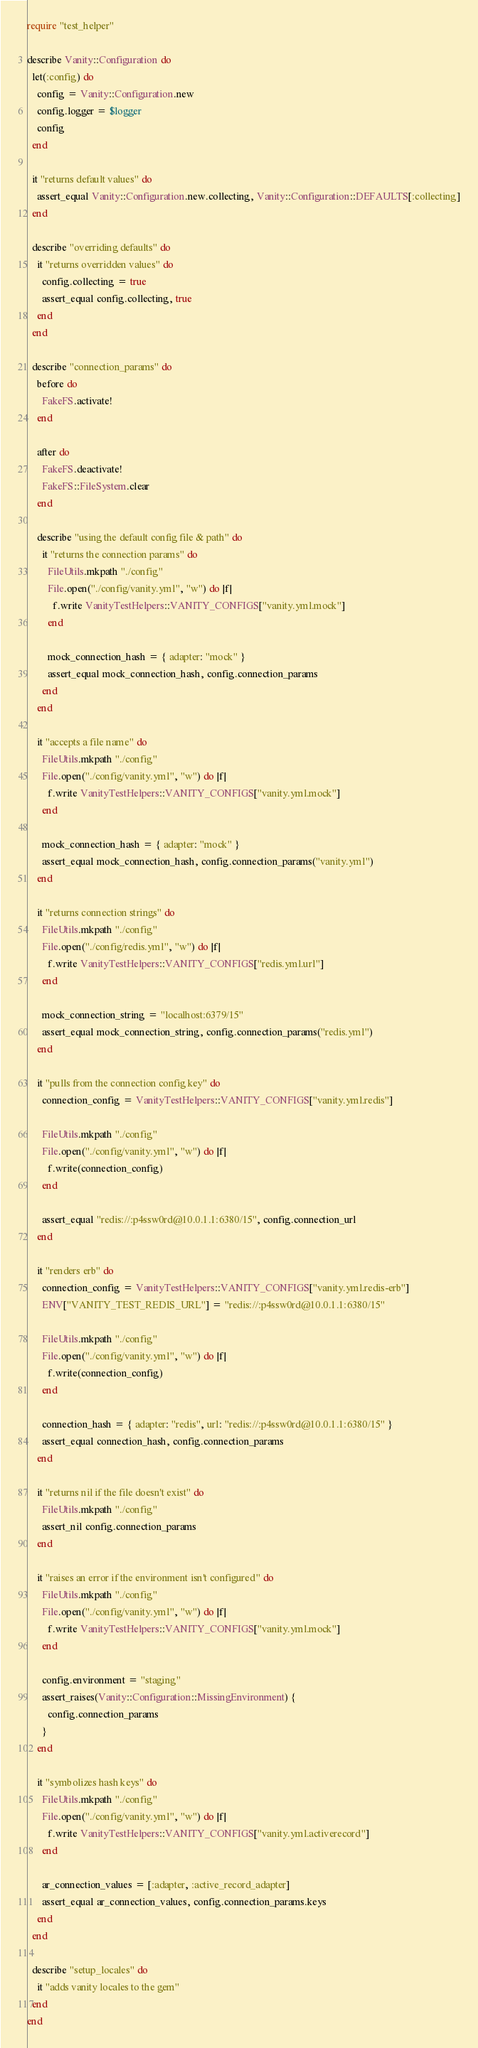<code> <loc_0><loc_0><loc_500><loc_500><_Ruby_>require "test_helper"

describe Vanity::Configuration do
  let(:config) do
    config = Vanity::Configuration.new
    config.logger = $logger
    config
  end

  it "returns default values" do
    assert_equal Vanity::Configuration.new.collecting, Vanity::Configuration::DEFAULTS[:collecting]
  end

  describe "overriding defaults" do
    it "returns overridden values" do
      config.collecting = true
      assert_equal config.collecting, true
    end
  end

  describe "connection_params" do
    before do
      FakeFS.activate!
    end

    after do
      FakeFS.deactivate!
      FakeFS::FileSystem.clear
    end

    describe "using the default config file & path" do
      it "returns the connection params" do
        FileUtils.mkpath "./config"
        File.open("./config/vanity.yml", "w") do |f|
          f.write VanityTestHelpers::VANITY_CONFIGS["vanity.yml.mock"]
        end

        mock_connection_hash = { adapter: "mock" }
        assert_equal mock_connection_hash, config.connection_params
      end
    end

    it "accepts a file name" do
      FileUtils.mkpath "./config"
      File.open("./config/vanity.yml", "w") do |f|
        f.write VanityTestHelpers::VANITY_CONFIGS["vanity.yml.mock"]
      end

      mock_connection_hash = { adapter: "mock" }
      assert_equal mock_connection_hash, config.connection_params("vanity.yml")
    end

    it "returns connection strings" do
      FileUtils.mkpath "./config"
      File.open("./config/redis.yml", "w") do |f|
        f.write VanityTestHelpers::VANITY_CONFIGS["redis.yml.url"]
      end

      mock_connection_string = "localhost:6379/15"
      assert_equal mock_connection_string, config.connection_params("redis.yml")
    end

    it "pulls from the connection config key" do
      connection_config = VanityTestHelpers::VANITY_CONFIGS["vanity.yml.redis"]

      FileUtils.mkpath "./config"
      File.open("./config/vanity.yml", "w") do |f|
        f.write(connection_config)
      end

      assert_equal "redis://:p4ssw0rd@10.0.1.1:6380/15", config.connection_url
    end

    it "renders erb" do
      connection_config = VanityTestHelpers::VANITY_CONFIGS["vanity.yml.redis-erb"]
      ENV["VANITY_TEST_REDIS_URL"] = "redis://:p4ssw0rd@10.0.1.1:6380/15"

      FileUtils.mkpath "./config"
      File.open("./config/vanity.yml", "w") do |f|
        f.write(connection_config)
      end

      connection_hash = { adapter: "redis", url: "redis://:p4ssw0rd@10.0.1.1:6380/15" }
      assert_equal connection_hash, config.connection_params
    end

    it "returns nil if the file doesn't exist" do
      FileUtils.mkpath "./config"
      assert_nil config.connection_params
    end

    it "raises an error if the environment isn't configured" do
      FileUtils.mkpath "./config"
      File.open("./config/vanity.yml", "w") do |f|
        f.write VanityTestHelpers::VANITY_CONFIGS["vanity.yml.mock"]
      end

      config.environment = "staging"
      assert_raises(Vanity::Configuration::MissingEnvironment) {
        config.connection_params
      }
    end

    it "symbolizes hash keys" do
      FileUtils.mkpath "./config"
      File.open("./config/vanity.yml", "w") do |f|
        f.write VanityTestHelpers::VANITY_CONFIGS["vanity.yml.activerecord"]
      end

      ar_connection_values = [:adapter, :active_record_adapter]
      assert_equal ar_connection_values, config.connection_params.keys
    end
  end

  describe "setup_locales" do
    it "adds vanity locales to the gem"
  end
end</code> 